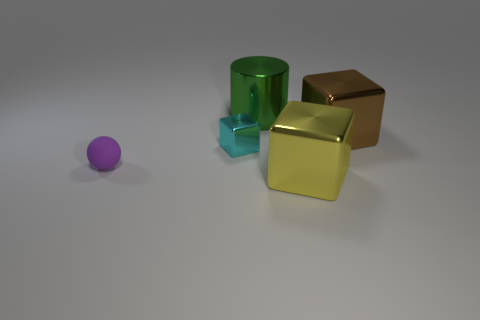Can you describe the lighting and shadows in the scene? The lighting in the image seems to be diffused, creating soft shadows. Each object casts a slight shadow against the light-colored surface, suggesting a single light source positioned above and to the left of the composition. 